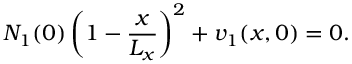<formula> <loc_0><loc_0><loc_500><loc_500>N _ { 1 } ( 0 ) \left ( 1 - \frac { x } { L _ { x } } \right ) ^ { 2 } + v _ { 1 } ( x , 0 ) = 0 .</formula> 